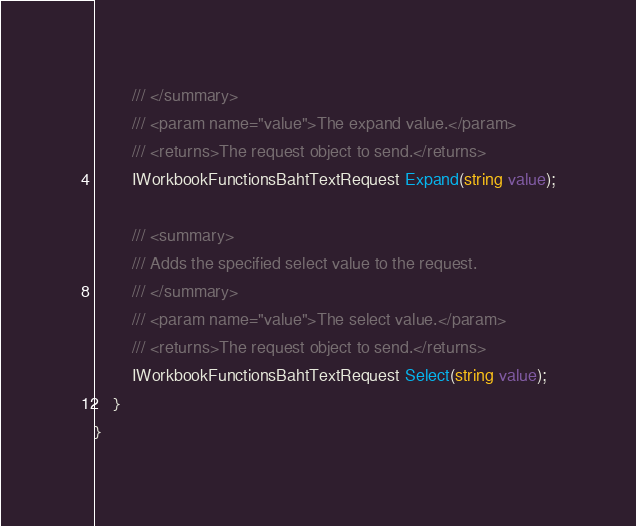<code> <loc_0><loc_0><loc_500><loc_500><_C#_>        /// </summary>
        /// <param name="value">The expand value.</param>
        /// <returns>The request object to send.</returns>
        IWorkbookFunctionsBahtTextRequest Expand(string value);

        /// <summary>
        /// Adds the specified select value to the request.
        /// </summary>
        /// <param name="value">The select value.</param>
        /// <returns>The request object to send.</returns>
        IWorkbookFunctionsBahtTextRequest Select(string value);
    }
}
</code> 